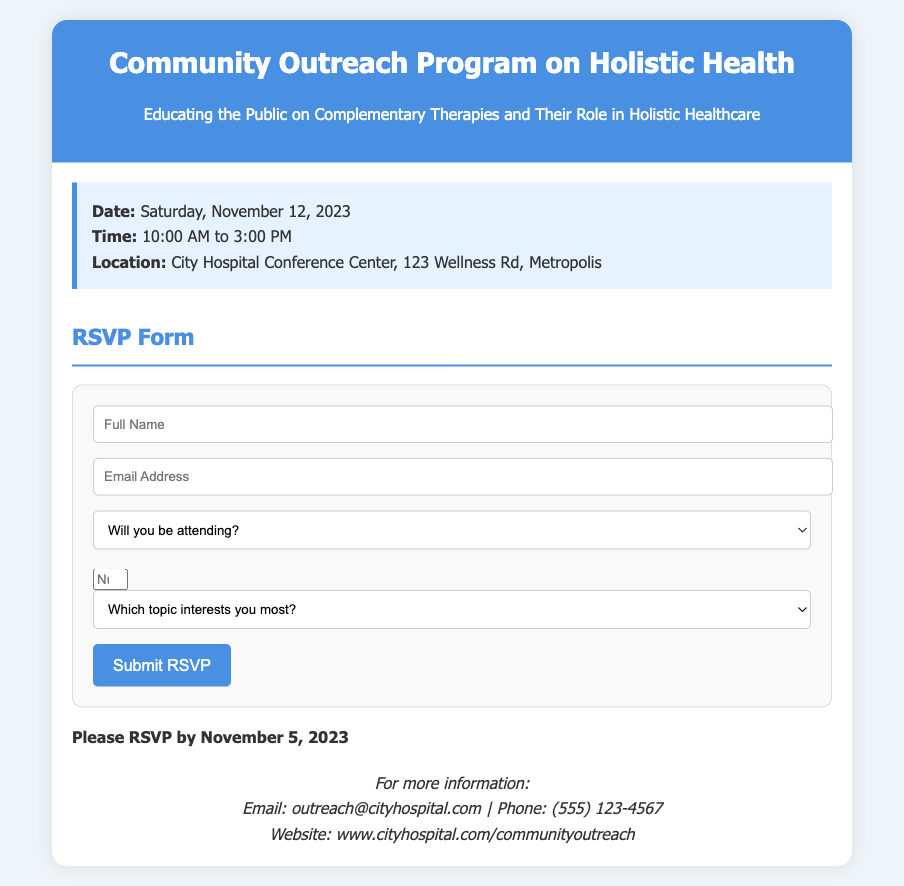what is the date of the event? The document mentions the event is scheduled for Saturday, November 12, 2023.
Answer: November 12, 2023 what time does the event start? The document states the event starts at 10:00 AM and ends at 3:00 PM.
Answer: 10:00 AM where is the event taking place? The location provided in the document is the City Hospital Conference Center, 123 Wellness Rd, Metropolis.
Answer: City Hospital Conference Center how many guests can I add in the RSVP? The RSVP form allows a minimum of 0 and a maximum of 3 additional guests to be added.
Answer: 3 by what date should I RSVP? The document specifies that RSVPs should be submitted by November 5, 2023.
Answer: November 5, 2023 what is one topic that can be selected in the RSVP? The form includes options such as "Demonstration of Complementary Therapies" for respondents to choose from.
Answer: Demonstration of Complementary Therapies how can I contact for more information? The document provides an email address, outreach@cityhospital.com, for inquiries regarding the event.
Answer: outreach@cityhospital.com what type of event is this? The document describes this as a Community Outreach Program on Holistic Health.
Answer: Community Outreach Program on Holistic Health who is organizing the event? The event is organized by City Hospital as indicated in the document.
Answer: City Hospital 